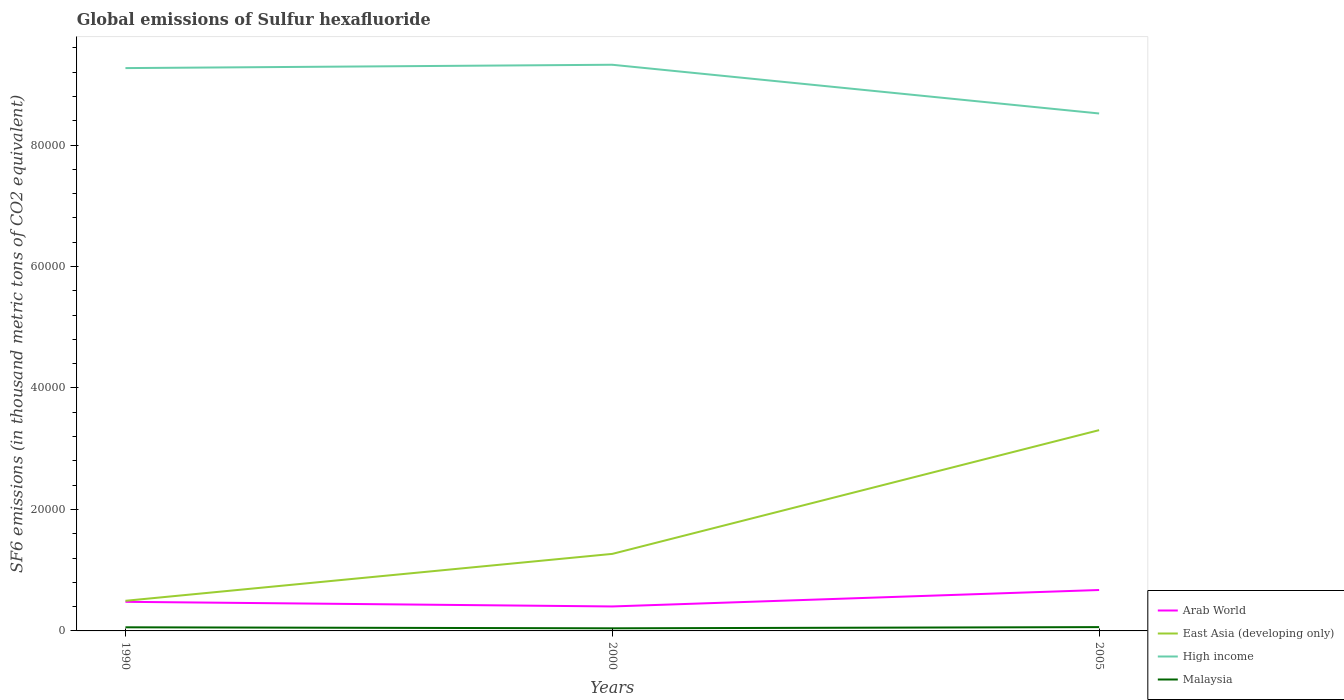How many different coloured lines are there?
Your response must be concise. 4. Does the line corresponding to Malaysia intersect with the line corresponding to East Asia (developing only)?
Make the answer very short. No. Across all years, what is the maximum global emissions of Sulfur hexafluoride in Arab World?
Offer a very short reply. 4028.4. In which year was the global emissions of Sulfur hexafluoride in Arab World maximum?
Your response must be concise. 2000. What is the total global emissions of Sulfur hexafluoride in Arab World in the graph?
Give a very brief answer. -2709.94. What is the difference between the highest and the second highest global emissions of Sulfur hexafluoride in High income?
Your answer should be very brief. 8021.59. What is the difference between the highest and the lowest global emissions of Sulfur hexafluoride in Malaysia?
Ensure brevity in your answer.  2. Is the global emissions of Sulfur hexafluoride in High income strictly greater than the global emissions of Sulfur hexafluoride in Malaysia over the years?
Offer a terse response. No. How many lines are there?
Offer a very short reply. 4. What is the difference between two consecutive major ticks on the Y-axis?
Keep it short and to the point. 2.00e+04. Are the values on the major ticks of Y-axis written in scientific E-notation?
Give a very brief answer. No. Where does the legend appear in the graph?
Offer a very short reply. Bottom right. What is the title of the graph?
Provide a succinct answer. Global emissions of Sulfur hexafluoride. What is the label or title of the Y-axis?
Your response must be concise. SF6 emissions (in thousand metric tons of CO2 equivalent). What is the SF6 emissions (in thousand metric tons of CO2 equivalent) of Arab World in 1990?
Offer a very short reply. 4791.4. What is the SF6 emissions (in thousand metric tons of CO2 equivalent) of East Asia (developing only) in 1990?
Provide a short and direct response. 4959.9. What is the SF6 emissions (in thousand metric tons of CO2 equivalent) in High income in 1990?
Make the answer very short. 9.27e+04. What is the SF6 emissions (in thousand metric tons of CO2 equivalent) in Malaysia in 1990?
Keep it short and to the point. 597.1. What is the SF6 emissions (in thousand metric tons of CO2 equivalent) in Arab World in 2000?
Make the answer very short. 4028.4. What is the SF6 emissions (in thousand metric tons of CO2 equivalent) of East Asia (developing only) in 2000?
Ensure brevity in your answer.  1.27e+04. What is the SF6 emissions (in thousand metric tons of CO2 equivalent) of High income in 2000?
Provide a succinct answer. 9.32e+04. What is the SF6 emissions (in thousand metric tons of CO2 equivalent) of Malaysia in 2000?
Keep it short and to the point. 428.7. What is the SF6 emissions (in thousand metric tons of CO2 equivalent) in Arab World in 2005?
Give a very brief answer. 6738.34. What is the SF6 emissions (in thousand metric tons of CO2 equivalent) in East Asia (developing only) in 2005?
Ensure brevity in your answer.  3.31e+04. What is the SF6 emissions (in thousand metric tons of CO2 equivalent) in High income in 2005?
Provide a short and direct response. 8.52e+04. What is the SF6 emissions (in thousand metric tons of CO2 equivalent) in Malaysia in 2005?
Your answer should be compact. 627. Across all years, what is the maximum SF6 emissions (in thousand metric tons of CO2 equivalent) in Arab World?
Provide a succinct answer. 6738.34. Across all years, what is the maximum SF6 emissions (in thousand metric tons of CO2 equivalent) of East Asia (developing only)?
Offer a very short reply. 3.31e+04. Across all years, what is the maximum SF6 emissions (in thousand metric tons of CO2 equivalent) of High income?
Your answer should be very brief. 9.32e+04. Across all years, what is the maximum SF6 emissions (in thousand metric tons of CO2 equivalent) of Malaysia?
Offer a very short reply. 627. Across all years, what is the minimum SF6 emissions (in thousand metric tons of CO2 equivalent) in Arab World?
Provide a succinct answer. 4028.4. Across all years, what is the minimum SF6 emissions (in thousand metric tons of CO2 equivalent) of East Asia (developing only)?
Give a very brief answer. 4959.9. Across all years, what is the minimum SF6 emissions (in thousand metric tons of CO2 equivalent) in High income?
Make the answer very short. 8.52e+04. Across all years, what is the minimum SF6 emissions (in thousand metric tons of CO2 equivalent) of Malaysia?
Give a very brief answer. 428.7. What is the total SF6 emissions (in thousand metric tons of CO2 equivalent) in Arab World in the graph?
Your answer should be very brief. 1.56e+04. What is the total SF6 emissions (in thousand metric tons of CO2 equivalent) in East Asia (developing only) in the graph?
Your answer should be compact. 5.07e+04. What is the total SF6 emissions (in thousand metric tons of CO2 equivalent) in High income in the graph?
Your response must be concise. 2.71e+05. What is the total SF6 emissions (in thousand metric tons of CO2 equivalent) in Malaysia in the graph?
Make the answer very short. 1652.8. What is the difference between the SF6 emissions (in thousand metric tons of CO2 equivalent) of Arab World in 1990 and that in 2000?
Your answer should be very brief. 763. What is the difference between the SF6 emissions (in thousand metric tons of CO2 equivalent) in East Asia (developing only) in 1990 and that in 2000?
Provide a short and direct response. -7723.7. What is the difference between the SF6 emissions (in thousand metric tons of CO2 equivalent) in High income in 1990 and that in 2000?
Offer a terse response. -551.2. What is the difference between the SF6 emissions (in thousand metric tons of CO2 equivalent) of Malaysia in 1990 and that in 2000?
Offer a very short reply. 168.4. What is the difference between the SF6 emissions (in thousand metric tons of CO2 equivalent) of Arab World in 1990 and that in 2005?
Provide a succinct answer. -1946.94. What is the difference between the SF6 emissions (in thousand metric tons of CO2 equivalent) of East Asia (developing only) in 1990 and that in 2005?
Offer a very short reply. -2.81e+04. What is the difference between the SF6 emissions (in thousand metric tons of CO2 equivalent) in High income in 1990 and that in 2005?
Provide a short and direct response. 7470.39. What is the difference between the SF6 emissions (in thousand metric tons of CO2 equivalent) of Malaysia in 1990 and that in 2005?
Keep it short and to the point. -29.9. What is the difference between the SF6 emissions (in thousand metric tons of CO2 equivalent) in Arab World in 2000 and that in 2005?
Make the answer very short. -2709.94. What is the difference between the SF6 emissions (in thousand metric tons of CO2 equivalent) of East Asia (developing only) in 2000 and that in 2005?
Make the answer very short. -2.04e+04. What is the difference between the SF6 emissions (in thousand metric tons of CO2 equivalent) in High income in 2000 and that in 2005?
Your response must be concise. 8021.59. What is the difference between the SF6 emissions (in thousand metric tons of CO2 equivalent) of Malaysia in 2000 and that in 2005?
Give a very brief answer. -198.3. What is the difference between the SF6 emissions (in thousand metric tons of CO2 equivalent) in Arab World in 1990 and the SF6 emissions (in thousand metric tons of CO2 equivalent) in East Asia (developing only) in 2000?
Ensure brevity in your answer.  -7892.2. What is the difference between the SF6 emissions (in thousand metric tons of CO2 equivalent) of Arab World in 1990 and the SF6 emissions (in thousand metric tons of CO2 equivalent) of High income in 2000?
Keep it short and to the point. -8.84e+04. What is the difference between the SF6 emissions (in thousand metric tons of CO2 equivalent) of Arab World in 1990 and the SF6 emissions (in thousand metric tons of CO2 equivalent) of Malaysia in 2000?
Provide a short and direct response. 4362.7. What is the difference between the SF6 emissions (in thousand metric tons of CO2 equivalent) of East Asia (developing only) in 1990 and the SF6 emissions (in thousand metric tons of CO2 equivalent) of High income in 2000?
Your answer should be compact. -8.83e+04. What is the difference between the SF6 emissions (in thousand metric tons of CO2 equivalent) in East Asia (developing only) in 1990 and the SF6 emissions (in thousand metric tons of CO2 equivalent) in Malaysia in 2000?
Your answer should be very brief. 4531.2. What is the difference between the SF6 emissions (in thousand metric tons of CO2 equivalent) in High income in 1990 and the SF6 emissions (in thousand metric tons of CO2 equivalent) in Malaysia in 2000?
Your answer should be very brief. 9.22e+04. What is the difference between the SF6 emissions (in thousand metric tons of CO2 equivalent) of Arab World in 1990 and the SF6 emissions (in thousand metric tons of CO2 equivalent) of East Asia (developing only) in 2005?
Offer a very short reply. -2.83e+04. What is the difference between the SF6 emissions (in thousand metric tons of CO2 equivalent) in Arab World in 1990 and the SF6 emissions (in thousand metric tons of CO2 equivalent) in High income in 2005?
Your response must be concise. -8.04e+04. What is the difference between the SF6 emissions (in thousand metric tons of CO2 equivalent) in Arab World in 1990 and the SF6 emissions (in thousand metric tons of CO2 equivalent) in Malaysia in 2005?
Give a very brief answer. 4164.4. What is the difference between the SF6 emissions (in thousand metric tons of CO2 equivalent) in East Asia (developing only) in 1990 and the SF6 emissions (in thousand metric tons of CO2 equivalent) in High income in 2005?
Make the answer very short. -8.02e+04. What is the difference between the SF6 emissions (in thousand metric tons of CO2 equivalent) of East Asia (developing only) in 1990 and the SF6 emissions (in thousand metric tons of CO2 equivalent) of Malaysia in 2005?
Offer a terse response. 4332.9. What is the difference between the SF6 emissions (in thousand metric tons of CO2 equivalent) in High income in 1990 and the SF6 emissions (in thousand metric tons of CO2 equivalent) in Malaysia in 2005?
Provide a succinct answer. 9.20e+04. What is the difference between the SF6 emissions (in thousand metric tons of CO2 equivalent) in Arab World in 2000 and the SF6 emissions (in thousand metric tons of CO2 equivalent) in East Asia (developing only) in 2005?
Your response must be concise. -2.90e+04. What is the difference between the SF6 emissions (in thousand metric tons of CO2 equivalent) of Arab World in 2000 and the SF6 emissions (in thousand metric tons of CO2 equivalent) of High income in 2005?
Your response must be concise. -8.12e+04. What is the difference between the SF6 emissions (in thousand metric tons of CO2 equivalent) of Arab World in 2000 and the SF6 emissions (in thousand metric tons of CO2 equivalent) of Malaysia in 2005?
Offer a very short reply. 3401.4. What is the difference between the SF6 emissions (in thousand metric tons of CO2 equivalent) of East Asia (developing only) in 2000 and the SF6 emissions (in thousand metric tons of CO2 equivalent) of High income in 2005?
Make the answer very short. -7.25e+04. What is the difference between the SF6 emissions (in thousand metric tons of CO2 equivalent) of East Asia (developing only) in 2000 and the SF6 emissions (in thousand metric tons of CO2 equivalent) of Malaysia in 2005?
Ensure brevity in your answer.  1.21e+04. What is the difference between the SF6 emissions (in thousand metric tons of CO2 equivalent) of High income in 2000 and the SF6 emissions (in thousand metric tons of CO2 equivalent) of Malaysia in 2005?
Keep it short and to the point. 9.26e+04. What is the average SF6 emissions (in thousand metric tons of CO2 equivalent) in Arab World per year?
Your response must be concise. 5186.05. What is the average SF6 emissions (in thousand metric tons of CO2 equivalent) in East Asia (developing only) per year?
Give a very brief answer. 1.69e+04. What is the average SF6 emissions (in thousand metric tons of CO2 equivalent) of High income per year?
Provide a succinct answer. 9.04e+04. What is the average SF6 emissions (in thousand metric tons of CO2 equivalent) of Malaysia per year?
Make the answer very short. 550.93. In the year 1990, what is the difference between the SF6 emissions (in thousand metric tons of CO2 equivalent) in Arab World and SF6 emissions (in thousand metric tons of CO2 equivalent) in East Asia (developing only)?
Give a very brief answer. -168.5. In the year 1990, what is the difference between the SF6 emissions (in thousand metric tons of CO2 equivalent) of Arab World and SF6 emissions (in thousand metric tons of CO2 equivalent) of High income?
Your answer should be very brief. -8.79e+04. In the year 1990, what is the difference between the SF6 emissions (in thousand metric tons of CO2 equivalent) of Arab World and SF6 emissions (in thousand metric tons of CO2 equivalent) of Malaysia?
Offer a terse response. 4194.3. In the year 1990, what is the difference between the SF6 emissions (in thousand metric tons of CO2 equivalent) in East Asia (developing only) and SF6 emissions (in thousand metric tons of CO2 equivalent) in High income?
Provide a succinct answer. -8.77e+04. In the year 1990, what is the difference between the SF6 emissions (in thousand metric tons of CO2 equivalent) of East Asia (developing only) and SF6 emissions (in thousand metric tons of CO2 equivalent) of Malaysia?
Give a very brief answer. 4362.8. In the year 1990, what is the difference between the SF6 emissions (in thousand metric tons of CO2 equivalent) of High income and SF6 emissions (in thousand metric tons of CO2 equivalent) of Malaysia?
Give a very brief answer. 9.21e+04. In the year 2000, what is the difference between the SF6 emissions (in thousand metric tons of CO2 equivalent) in Arab World and SF6 emissions (in thousand metric tons of CO2 equivalent) in East Asia (developing only)?
Provide a succinct answer. -8655.2. In the year 2000, what is the difference between the SF6 emissions (in thousand metric tons of CO2 equivalent) in Arab World and SF6 emissions (in thousand metric tons of CO2 equivalent) in High income?
Provide a short and direct response. -8.92e+04. In the year 2000, what is the difference between the SF6 emissions (in thousand metric tons of CO2 equivalent) in Arab World and SF6 emissions (in thousand metric tons of CO2 equivalent) in Malaysia?
Offer a terse response. 3599.7. In the year 2000, what is the difference between the SF6 emissions (in thousand metric tons of CO2 equivalent) of East Asia (developing only) and SF6 emissions (in thousand metric tons of CO2 equivalent) of High income?
Your response must be concise. -8.05e+04. In the year 2000, what is the difference between the SF6 emissions (in thousand metric tons of CO2 equivalent) in East Asia (developing only) and SF6 emissions (in thousand metric tons of CO2 equivalent) in Malaysia?
Offer a terse response. 1.23e+04. In the year 2000, what is the difference between the SF6 emissions (in thousand metric tons of CO2 equivalent) in High income and SF6 emissions (in thousand metric tons of CO2 equivalent) in Malaysia?
Your response must be concise. 9.28e+04. In the year 2005, what is the difference between the SF6 emissions (in thousand metric tons of CO2 equivalent) in Arab World and SF6 emissions (in thousand metric tons of CO2 equivalent) in East Asia (developing only)?
Provide a short and direct response. -2.63e+04. In the year 2005, what is the difference between the SF6 emissions (in thousand metric tons of CO2 equivalent) of Arab World and SF6 emissions (in thousand metric tons of CO2 equivalent) of High income?
Ensure brevity in your answer.  -7.85e+04. In the year 2005, what is the difference between the SF6 emissions (in thousand metric tons of CO2 equivalent) of Arab World and SF6 emissions (in thousand metric tons of CO2 equivalent) of Malaysia?
Make the answer very short. 6111.34. In the year 2005, what is the difference between the SF6 emissions (in thousand metric tons of CO2 equivalent) in East Asia (developing only) and SF6 emissions (in thousand metric tons of CO2 equivalent) in High income?
Give a very brief answer. -5.21e+04. In the year 2005, what is the difference between the SF6 emissions (in thousand metric tons of CO2 equivalent) in East Asia (developing only) and SF6 emissions (in thousand metric tons of CO2 equivalent) in Malaysia?
Provide a short and direct response. 3.24e+04. In the year 2005, what is the difference between the SF6 emissions (in thousand metric tons of CO2 equivalent) in High income and SF6 emissions (in thousand metric tons of CO2 equivalent) in Malaysia?
Make the answer very short. 8.46e+04. What is the ratio of the SF6 emissions (in thousand metric tons of CO2 equivalent) in Arab World in 1990 to that in 2000?
Your answer should be compact. 1.19. What is the ratio of the SF6 emissions (in thousand metric tons of CO2 equivalent) in East Asia (developing only) in 1990 to that in 2000?
Provide a short and direct response. 0.39. What is the ratio of the SF6 emissions (in thousand metric tons of CO2 equivalent) of High income in 1990 to that in 2000?
Make the answer very short. 0.99. What is the ratio of the SF6 emissions (in thousand metric tons of CO2 equivalent) of Malaysia in 1990 to that in 2000?
Keep it short and to the point. 1.39. What is the ratio of the SF6 emissions (in thousand metric tons of CO2 equivalent) in Arab World in 1990 to that in 2005?
Your response must be concise. 0.71. What is the ratio of the SF6 emissions (in thousand metric tons of CO2 equivalent) in High income in 1990 to that in 2005?
Offer a very short reply. 1.09. What is the ratio of the SF6 emissions (in thousand metric tons of CO2 equivalent) of Malaysia in 1990 to that in 2005?
Offer a terse response. 0.95. What is the ratio of the SF6 emissions (in thousand metric tons of CO2 equivalent) of Arab World in 2000 to that in 2005?
Offer a very short reply. 0.6. What is the ratio of the SF6 emissions (in thousand metric tons of CO2 equivalent) of East Asia (developing only) in 2000 to that in 2005?
Your answer should be compact. 0.38. What is the ratio of the SF6 emissions (in thousand metric tons of CO2 equivalent) of High income in 2000 to that in 2005?
Ensure brevity in your answer.  1.09. What is the ratio of the SF6 emissions (in thousand metric tons of CO2 equivalent) of Malaysia in 2000 to that in 2005?
Your answer should be compact. 0.68. What is the difference between the highest and the second highest SF6 emissions (in thousand metric tons of CO2 equivalent) of Arab World?
Keep it short and to the point. 1946.94. What is the difference between the highest and the second highest SF6 emissions (in thousand metric tons of CO2 equivalent) in East Asia (developing only)?
Your answer should be very brief. 2.04e+04. What is the difference between the highest and the second highest SF6 emissions (in thousand metric tons of CO2 equivalent) in High income?
Your response must be concise. 551.2. What is the difference between the highest and the second highest SF6 emissions (in thousand metric tons of CO2 equivalent) in Malaysia?
Make the answer very short. 29.9. What is the difference between the highest and the lowest SF6 emissions (in thousand metric tons of CO2 equivalent) of Arab World?
Give a very brief answer. 2709.94. What is the difference between the highest and the lowest SF6 emissions (in thousand metric tons of CO2 equivalent) of East Asia (developing only)?
Keep it short and to the point. 2.81e+04. What is the difference between the highest and the lowest SF6 emissions (in thousand metric tons of CO2 equivalent) of High income?
Provide a succinct answer. 8021.59. What is the difference between the highest and the lowest SF6 emissions (in thousand metric tons of CO2 equivalent) of Malaysia?
Provide a short and direct response. 198.3. 